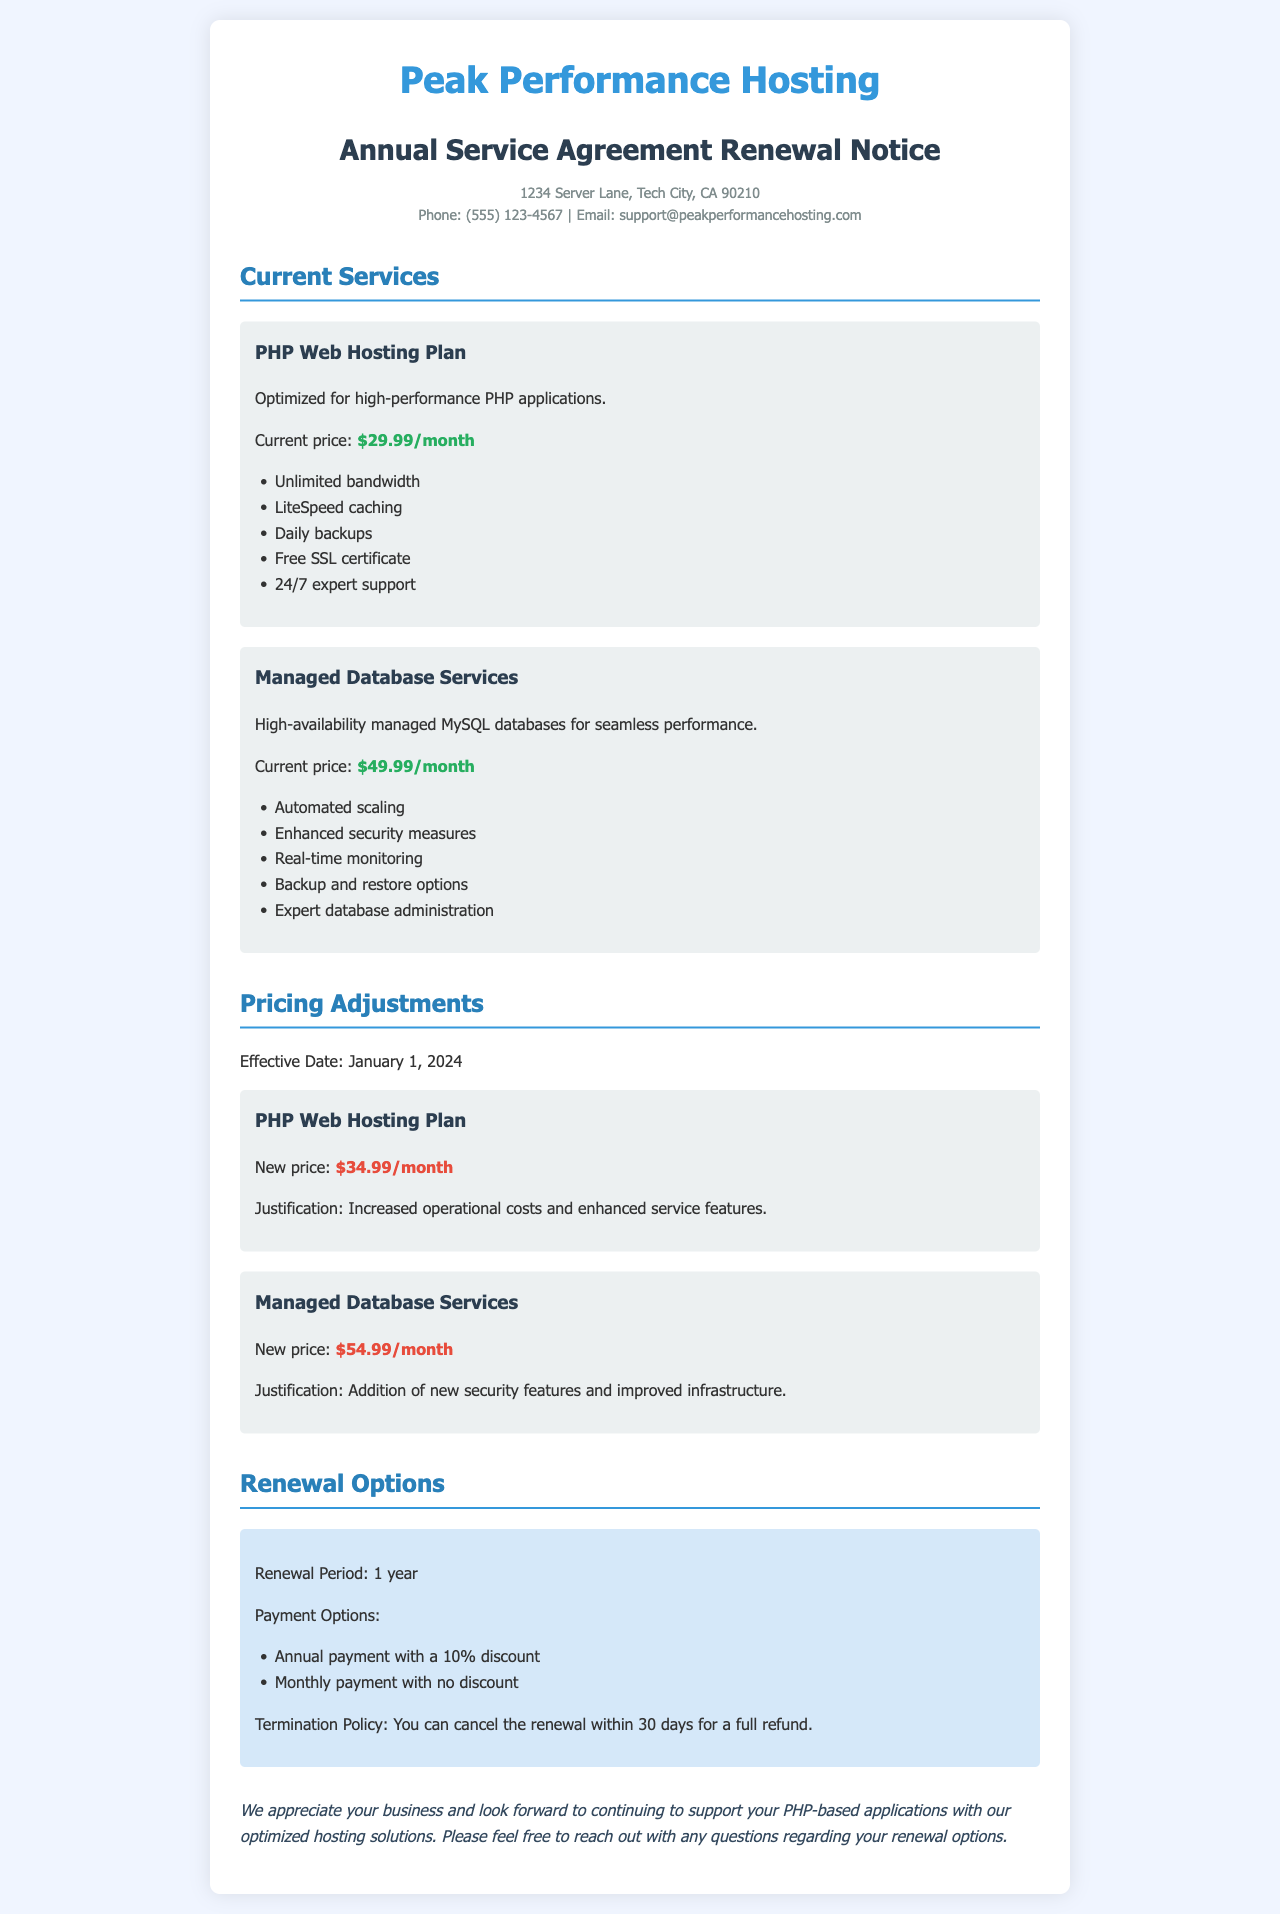What is the monthly price of the PHP Web Hosting Plan? The current monthly price of the PHP Web Hosting Plan is provided in the document as $29.99.
Answer: $29.99 What is the new price for Managed Database Services? The new price for Managed Database Services has been stated in the document as $54.99/month, effective January 1, 2024.
Answer: $54.99/month What is the annual renewal payment discount? The document specifies that there is a 10% discount for annual payment during the renewal period.
Answer: 10% What features does the PHP Web Hosting Plan include? The document outlines several features of the PHP Web Hosting Plan, including unlimited bandwidth, LiteSpeed caching, daily backups, a free SSL certificate, and 24/7 expert support.
Answer: Unlimited bandwidth, LiteSpeed caching, daily backups, free SSL certificate, 24/7 expert support What is the termination policy for the renewal? The termination policy states that cancellation of the renewal can be done within 30 days for a full refund, as mentioned in the renewal options section.
Answer: 30 days What is the effective date for the pricing adjustments? The document clearly states that the effective date for the pricing adjustments is January 1, 2024.
Answer: January 1, 2024 What is the current price of the Managed Database Services? The current price for the Managed Database Services is specifically listed as $49.99/month in the document.
Answer: $49.99/month What is the renewal period mentioned in the document? The renewal period is specified as 1 year in the renewal options section of the document.
Answer: 1 year 